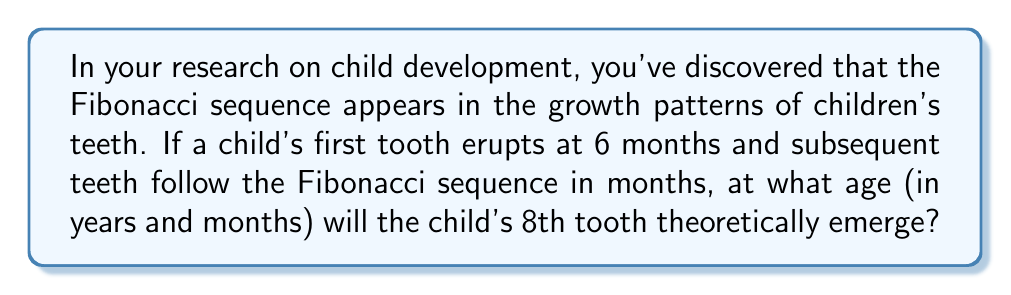What is the answer to this math problem? Let's approach this step-by-step:

1) First, recall the Fibonacci sequence: 
   $F_n = F_{n-1} + F_{n-2}$, where $F_1 = F_2 = 1$

2) The sequence starts: 1, 1, 2, 3, 5, 8, 13, 21, ...

3) In this scenario, the first tooth emerges at 6 months. We need to add this to each term in the sequence:
   6, 7, 8, 9, 11, 14, 19, 27, ...

4) The 8th tooth corresponds to the 8th term in this modified sequence, which is 27.

5) 27 months need to be converted to years and months:
   $$\text{Years} = \lfloor\frac{27}{12}\rfloor = 2$$
   $$\text{Remaining months} = 27 \bmod 12 = 3$$

Therefore, the 8th tooth would theoretically emerge when the child is 2 years and 3 months old.
Answer: 2 years and 3 months 